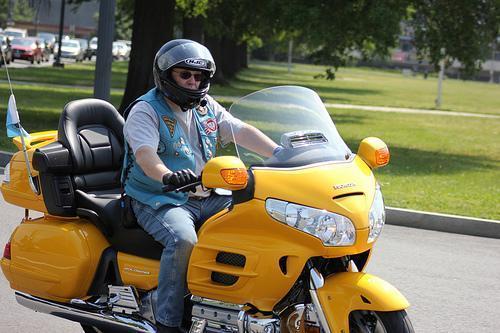How many motorcycles are in the photo?
Give a very brief answer. 1. 